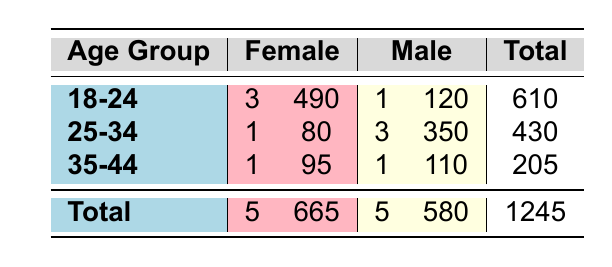What is the total attendance of female artists in the 18-24 age group? The attendance for female artists in the 18-24 age group includes Celeste (150) and AURORA (200) and Lola Young (140). Adding these values gives us 150 + 200 + 140 = 490.
Answer: 490 How many male artists performed in the 25-34 age group? There are 3 male artists in the 25-34 age group: Riton, Tom Misch, and Sam Fender.
Answer: 3 What is the attendance of the artist with the highest attendance in the 35-44 age group? In the 35-44 age group, Years & Years has an attendance of 110 (male), while Neneh Cherry has 95 (female). The highest is 110.
Answer: 110 Is the total attendance for male artists higher than that for female artists? The total attendance for male artists is 580, while female artists have a total of 665. Since 580 is less than 665, the statement is false.
Answer: No What is the average attendance of female artists across all age groups? The total attendance for female artists is 665 over 5 artists. To find the average, we calculate 665 divided by 5, which equals 133.
Answer: 133 What is the difference in total attendance between the 25-34 and 18-24 age groups? The total attendance for the 18-24 age group is 610, and for the 25-34 age group it is 430. The difference is 610 - 430 = 180.
Answer: 180 Which age group had the highest total attendance? The total attendance for each age group is: 18-24 (610), 25-34 (430), and 35-44 (205). The highest total is for the 18-24 age group.
Answer: 18-24 Are there more female artists overall than male artists in the total data? There are 5 female artists and 5 male artists. Since both counts are equal, there are not more female artists than male.
Answer: No Calculate the total attendance for artists aged 25-34 and gendered male. The attendance for male artists aged 25-34 includes Riton (100), Tom Misch (90), and Sam Fender (160). The total is 100 + 90 + 160 = 350.
Answer: 350 